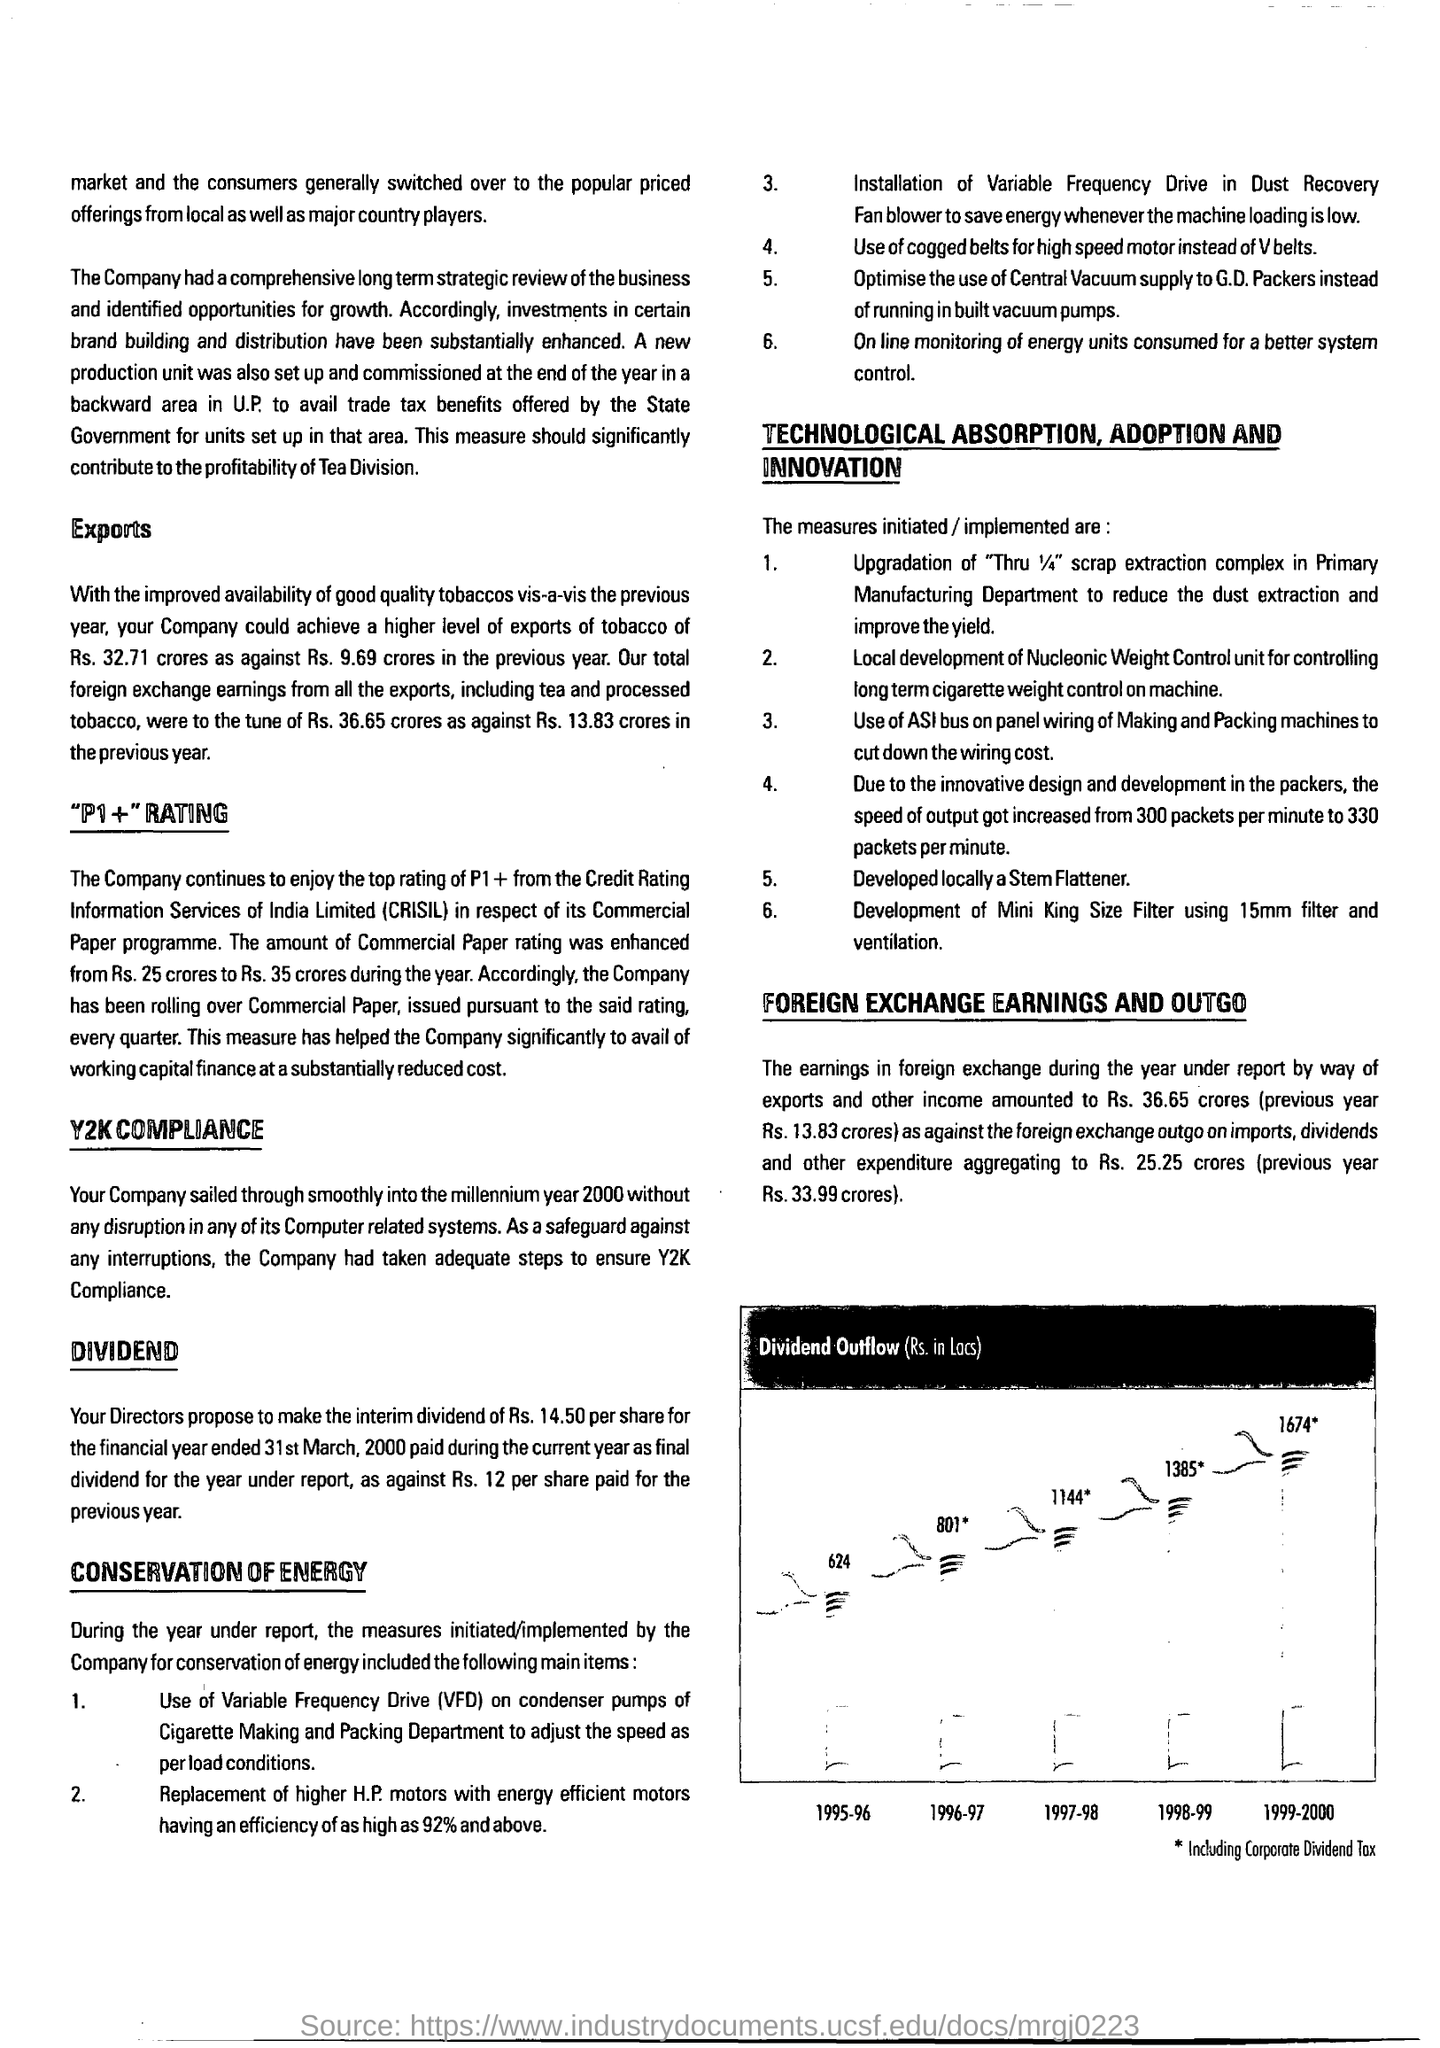What is the first title in the document?
Your response must be concise. EXPORTS. 